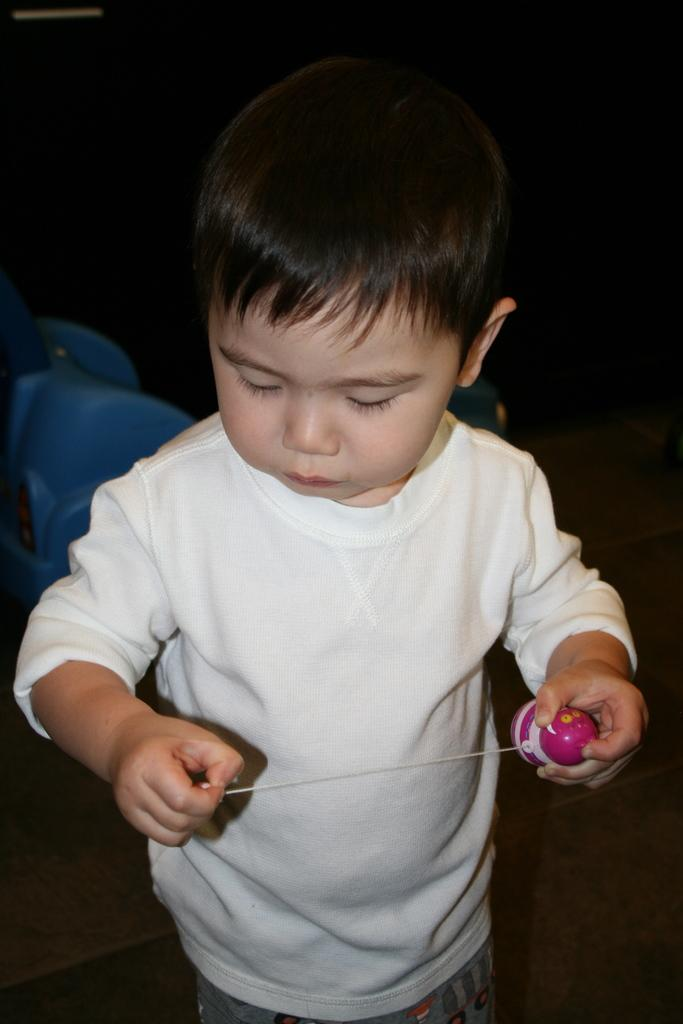What is the person in the image wearing? The person is wearing a cream-colored t-shirt in the image. What can be seen to the left of the person? There is a blue object to the left of the person. What color is the background of the image? The background of the image is black. What type of pencil can be seen in the person's hand in the image? There is no pencil visible in the person's hand in the image. How far does the range of the person's vision extend in the image? The range of the person's vision is not mentioned in the image, and it is not possible to determine this based on the provided facts. 